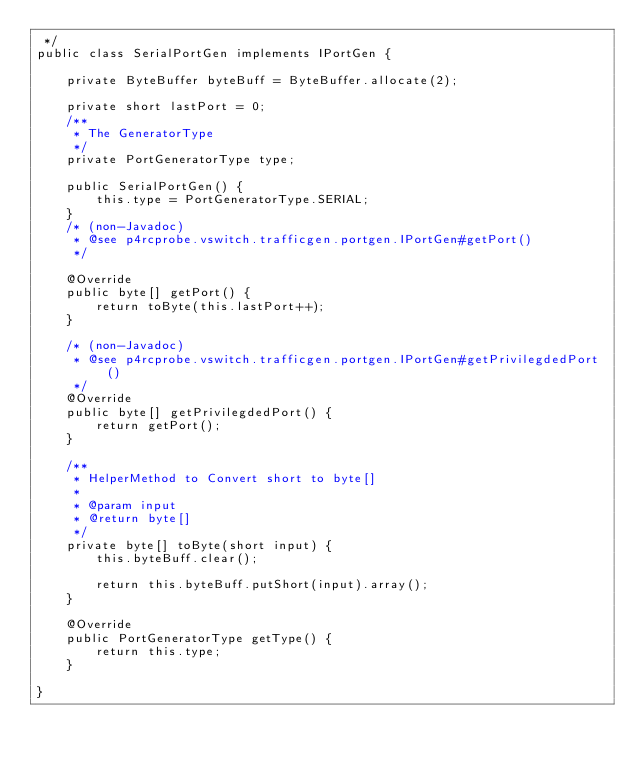<code> <loc_0><loc_0><loc_500><loc_500><_Java_> */
public class SerialPortGen implements IPortGen {

    private ByteBuffer byteBuff = ByteBuffer.allocate(2);

    private short lastPort = 0;
    /**
     * The GeneratorType
     */
    private PortGeneratorType type;

    public SerialPortGen() {
        this.type = PortGeneratorType.SERIAL;
    }
    /* (non-Javadoc)
     * @see p4rcprobe.vswitch.trafficgen.portgen.IPortGen#getPort()
     */

    @Override
    public byte[] getPort() {
        return toByte(this.lastPort++);
    }

    /* (non-Javadoc)
     * @see p4rcprobe.vswitch.trafficgen.portgen.IPortGen#getPrivilegdedPort()
     */
    @Override
    public byte[] getPrivilegdedPort() {
        return getPort();
    }

    /**
     * HelperMethod to Convert short to byte[]
     *
     * @param input
     * @return byte[]
     */
    private byte[] toByte(short input) {
        this.byteBuff.clear();

        return this.byteBuff.putShort(input).array();
    }

    @Override
    public PortGeneratorType getType() {
        return this.type;
    }

}
</code> 